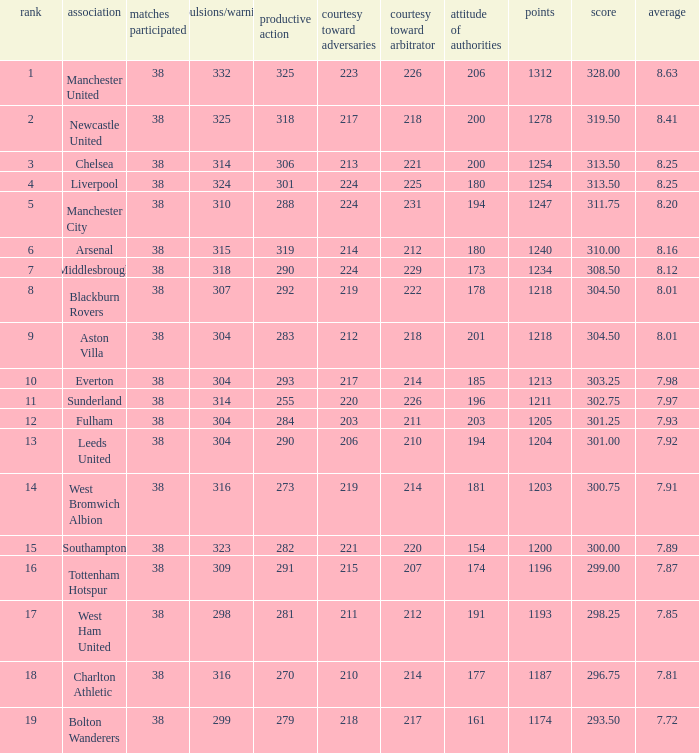Name the most red/yellow cards for positive play being 255 314.0. 